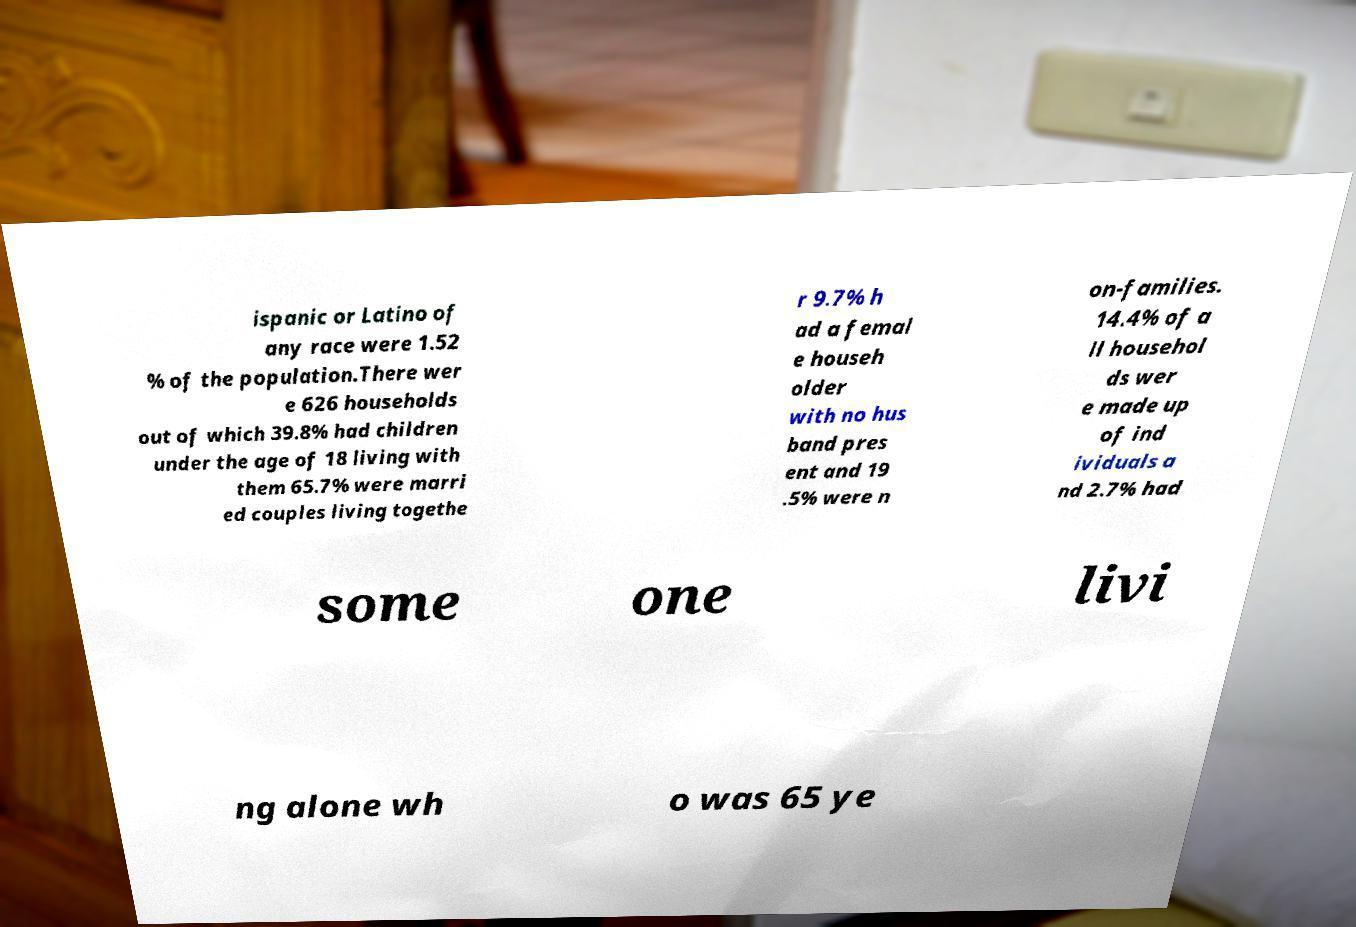Can you read and provide the text displayed in the image?This photo seems to have some interesting text. Can you extract and type it out for me? ispanic or Latino of any race were 1.52 % of the population.There wer e 626 households out of which 39.8% had children under the age of 18 living with them 65.7% were marri ed couples living togethe r 9.7% h ad a femal e househ older with no hus band pres ent and 19 .5% were n on-families. 14.4% of a ll househol ds wer e made up of ind ividuals a nd 2.7% had some one livi ng alone wh o was 65 ye 